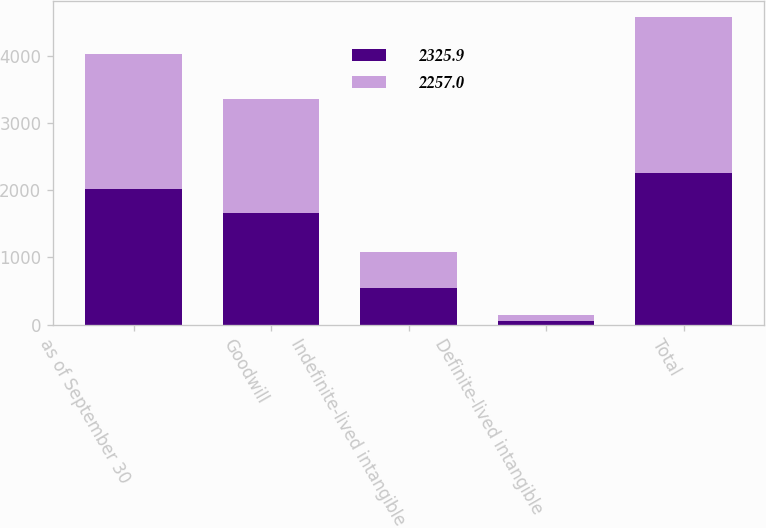<chart> <loc_0><loc_0><loc_500><loc_500><stacked_bar_chart><ecel><fcel>as of September 30<fcel>Goodwill<fcel>Indefinite-lived intangible<fcel>Definite-lived intangible<fcel>Total<nl><fcel>2325.9<fcel>2015<fcel>1661.2<fcel>538.3<fcel>57.5<fcel>2257<nl><fcel>2257<fcel>2014<fcel>1691<fcel>547.4<fcel>87.5<fcel>2325.9<nl></chart> 